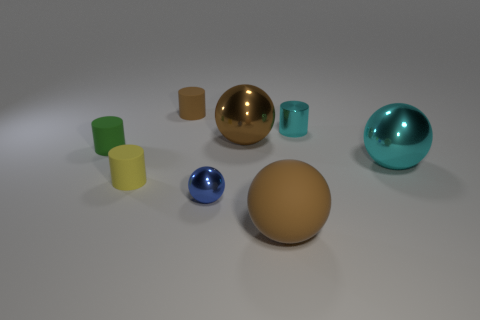Subtract 1 cylinders. How many cylinders are left? 3 Add 1 cyan metallic spheres. How many objects exist? 9 Add 4 big cyan shiny balls. How many big cyan shiny balls exist? 5 Subtract 1 cyan balls. How many objects are left? 7 Subtract all big cyan metal spheres. Subtract all tiny yellow matte cylinders. How many objects are left? 6 Add 5 big metallic objects. How many big metallic objects are left? 7 